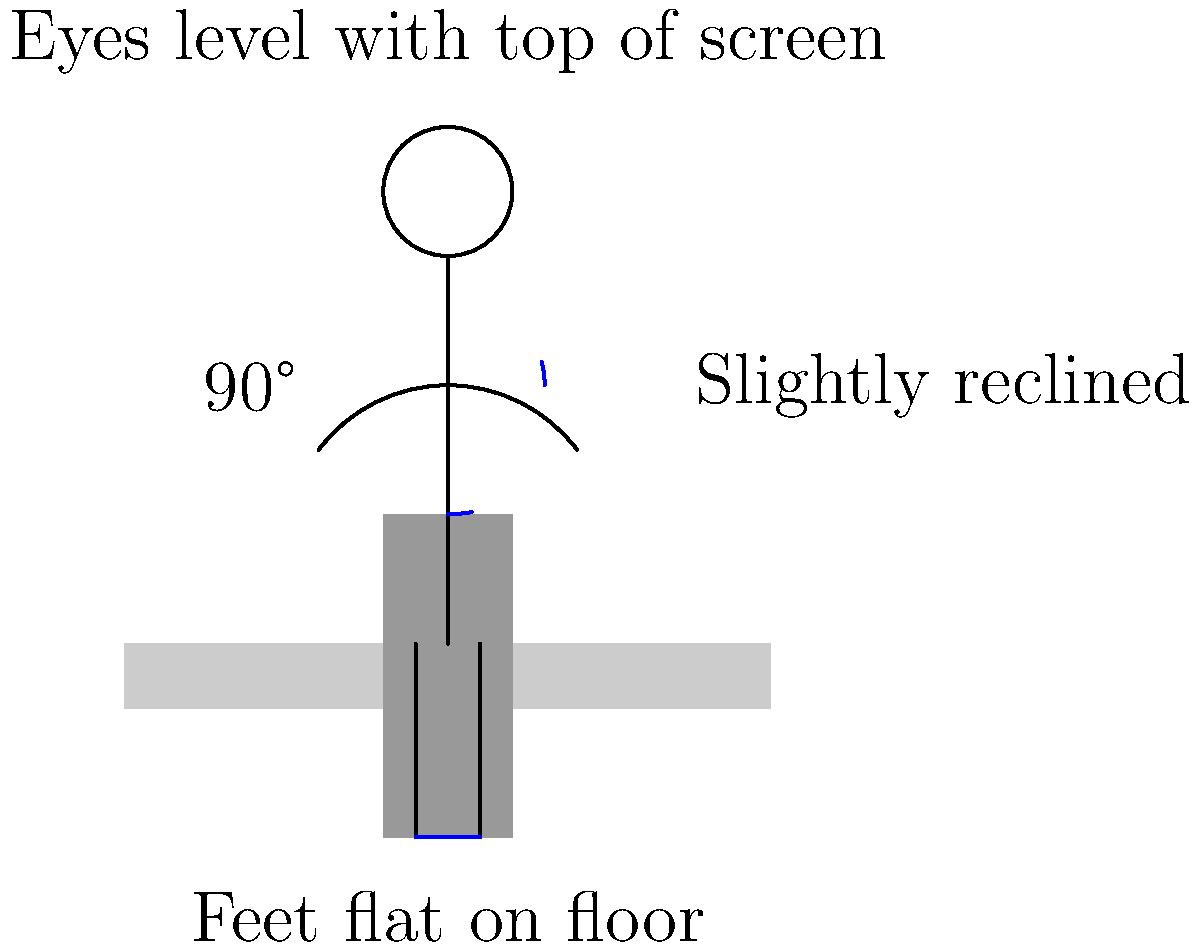As a social worker conducting interviews with potential witnesses, you often spend long hours at your desk. Which of the following ergonomic principles is NOT correctly illustrated in the diagram for maintaining proper posture while sitting at a desk? Let's analyze the ergonomic principles illustrated in the diagram:

1. Back posture: The diagram shows a slightly reclined position, which is correct. A slight recline (about 100-110 degrees) reduces pressure on the spine.

2. Eye level: The diagram indicates that eyes should be level with the top of the screen, which is correct. This helps prevent neck strain.

3. Arm position: The arms are shown at about a 90-degree angle, which is correct. This reduces strain on the shoulders and wrists.

4. Feet position: The diagram shows feet flat on the floor, which is correct. This promotes good circulation and reduces pressure on the thighs.

5. Hip angle: The diagram shows approximately a 90-degree angle at the hips, which is correct. This helps maintain proper spine alignment.

However, the diagram does not explicitly show or mention anything about the position of the keyboard and mouse. For proper ergonomics, the keyboard and mouse should be positioned so that the elbows can remain close to the body and the wrists are straight.

Therefore, the principle that is NOT correctly illustrated or mentioned is the positioning of the keyboard and mouse.
Answer: Keyboard and mouse positioning 